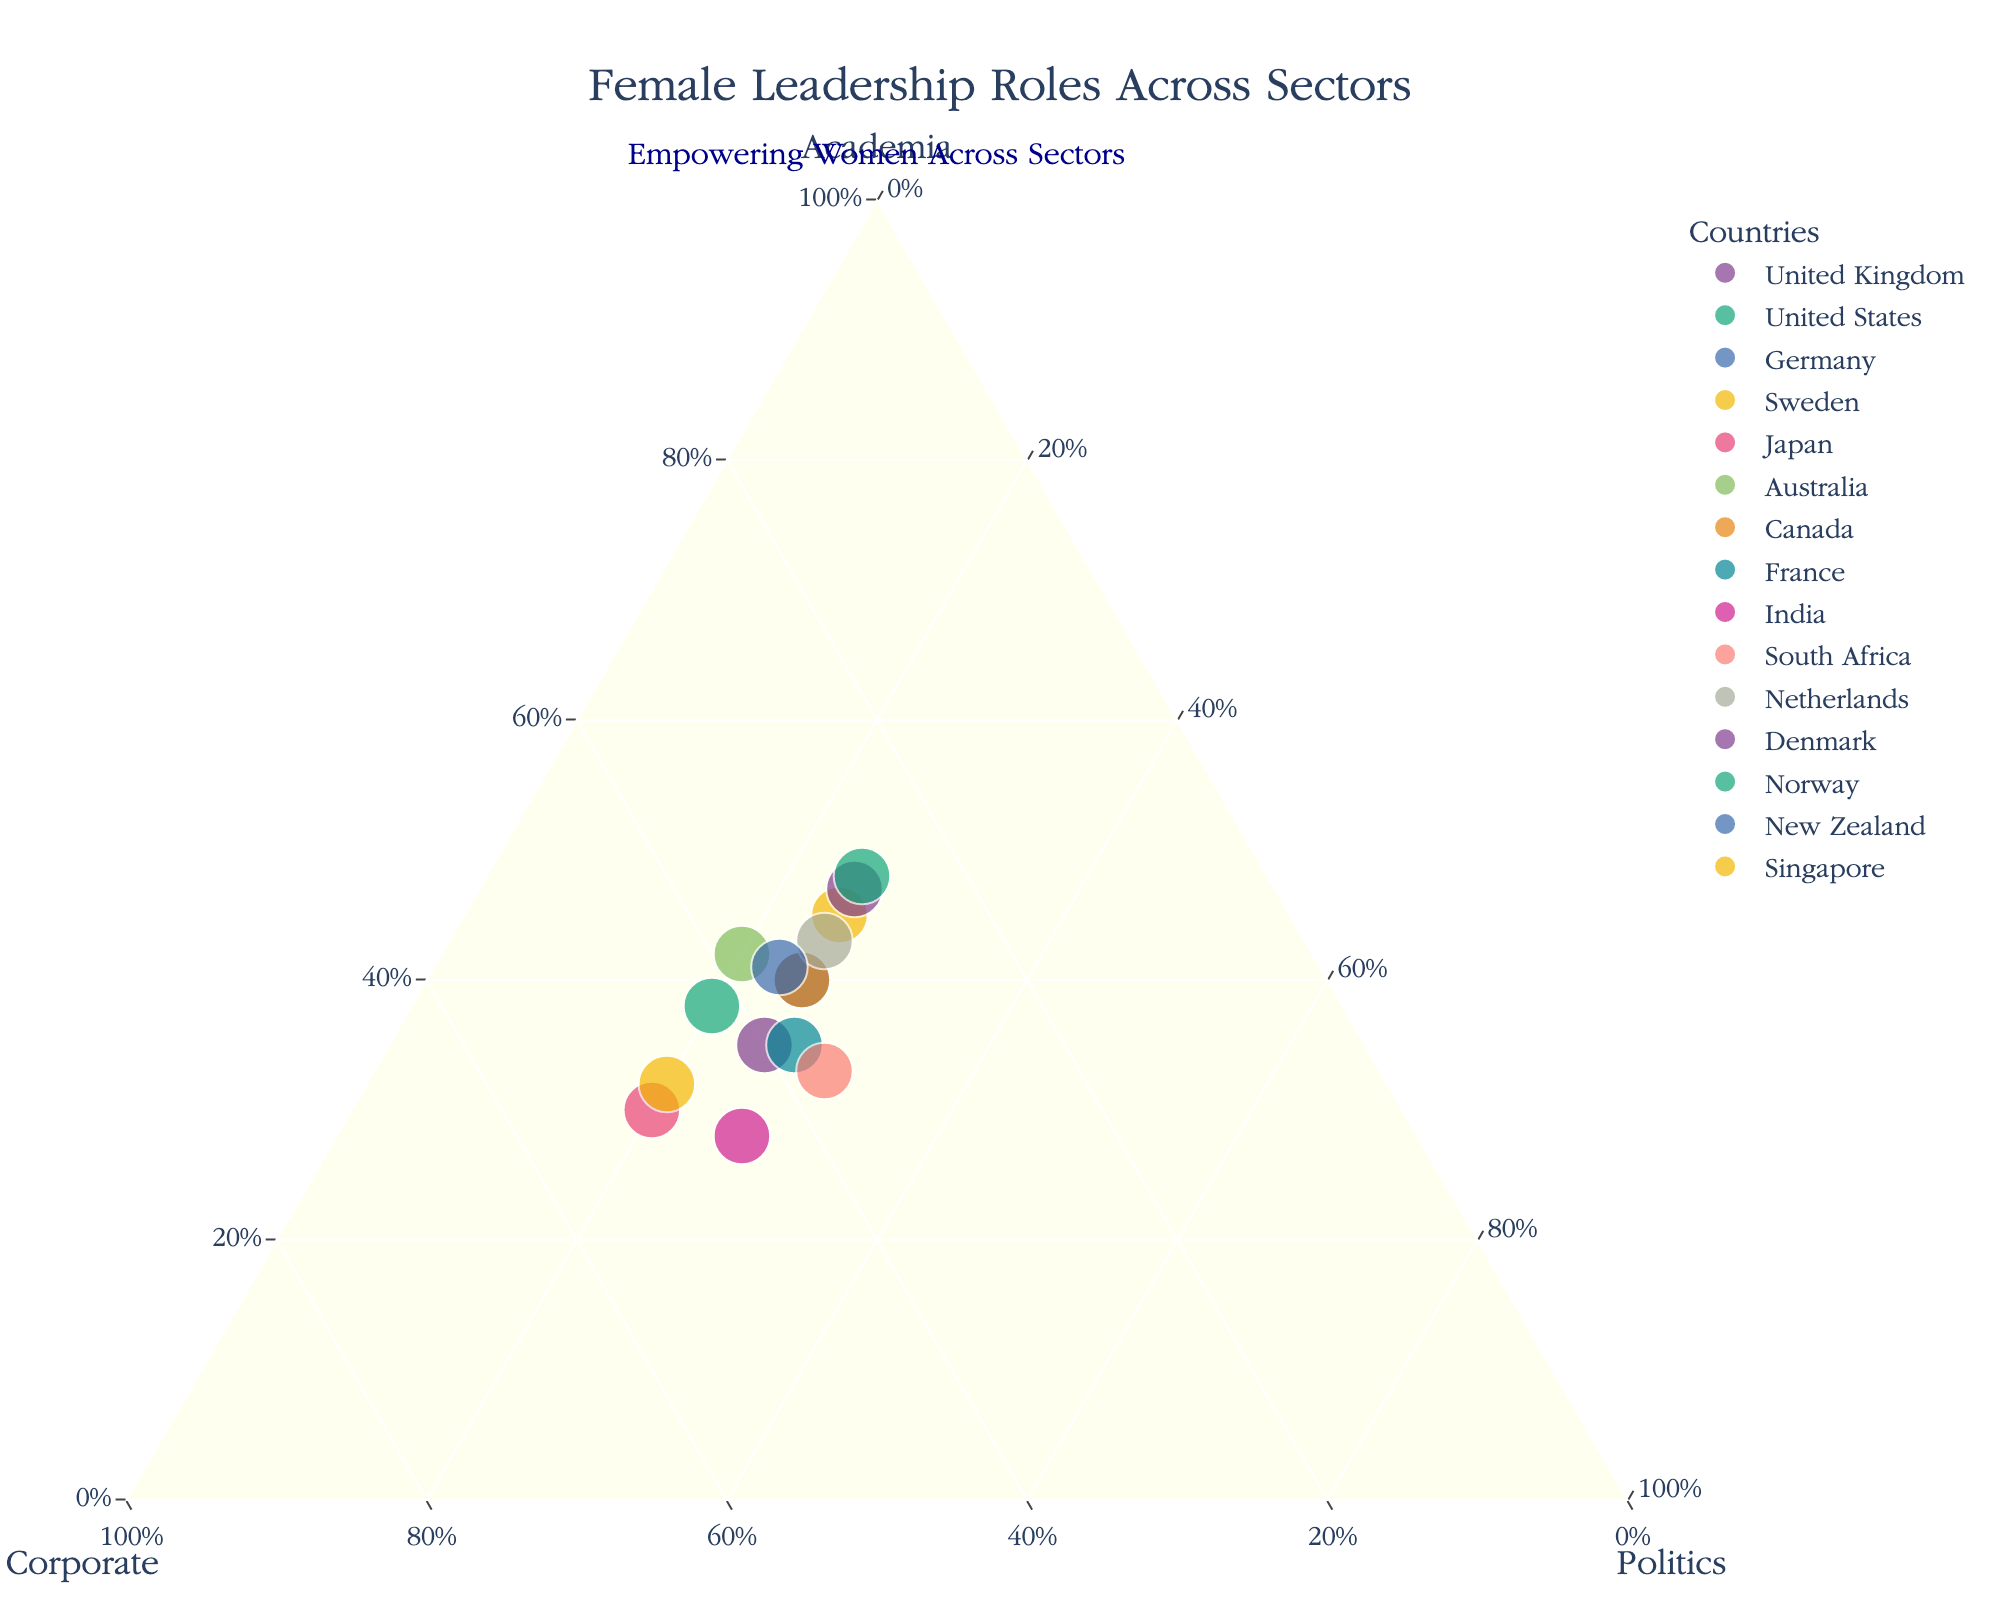What is the title of the figure? Look at the top of the figure where the title is usually displayed.
Answer: Female Leadership Roles Across Sectors Which country has the highest percentage of women in academia? Locate the point that is furthest along the "Academia" axis. This represents the normalized value.
Answer: Norway How do the percentages of women in corporate sector compare between Japan and Singapore? Observe the positions of Japan and Singapore along the "Corporate" axis to see which is higher.
Answer: Singapore has a higher percentage What three roles are being compared in this plot? Review the labels on the three axes on the ternary plot which represent different sectors.
Answer: Academia, Corporate, Politics Which country has the lowest representation of women in politics? Look for the country positioned lowest along the "Politics" axis.
Answer: Japan, United States, Australia, and Singapore all have the lowest at 20% How does the representation of women in academia in Germany compare to that in Sweden? Notice the positions of Germany and Sweden along the "Academia" axis and compare which is further along.
Answer: Sweden has a higher representation Is there any country where women's representation is balanced across all three sectors? Check if there are any points located in the middle indicating similar percentages across all three axes.
Answer: No, there is no country with balanced representation How many countries have a higher percentage of women in the corporate sector than in politics? Count the countries that are positioned higher along the "Corporate" axis compared to the "Politics" axis.
Answer: Nine countries Between the United Kingdom and France, which has a greater percentage of women in politics? Compare the positions of the United Kingdom and France along the "Politics" axis.
Answer: France What common sector appears to have the highest representation of women across most countries? Observe the general trend of data points across the plot to determine the sector with the most points leaning towards it.
Answer: Corporate 